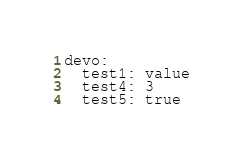Convert code to text. <code><loc_0><loc_0><loc_500><loc_500><_YAML_>devo:
  test1: value
  test4: 3
  test5: true
</code> 